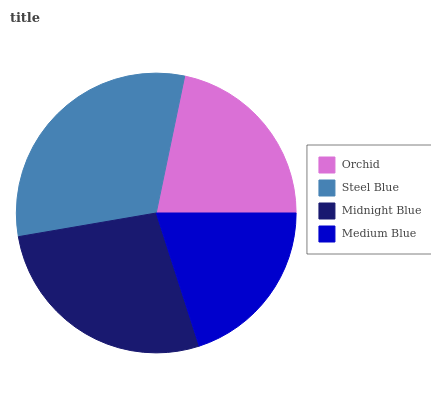Is Medium Blue the minimum?
Answer yes or no. Yes. Is Steel Blue the maximum?
Answer yes or no. Yes. Is Midnight Blue the minimum?
Answer yes or no. No. Is Midnight Blue the maximum?
Answer yes or no. No. Is Steel Blue greater than Midnight Blue?
Answer yes or no. Yes. Is Midnight Blue less than Steel Blue?
Answer yes or no. Yes. Is Midnight Blue greater than Steel Blue?
Answer yes or no. No. Is Steel Blue less than Midnight Blue?
Answer yes or no. No. Is Midnight Blue the high median?
Answer yes or no. Yes. Is Orchid the low median?
Answer yes or no. Yes. Is Medium Blue the high median?
Answer yes or no. No. Is Medium Blue the low median?
Answer yes or no. No. 